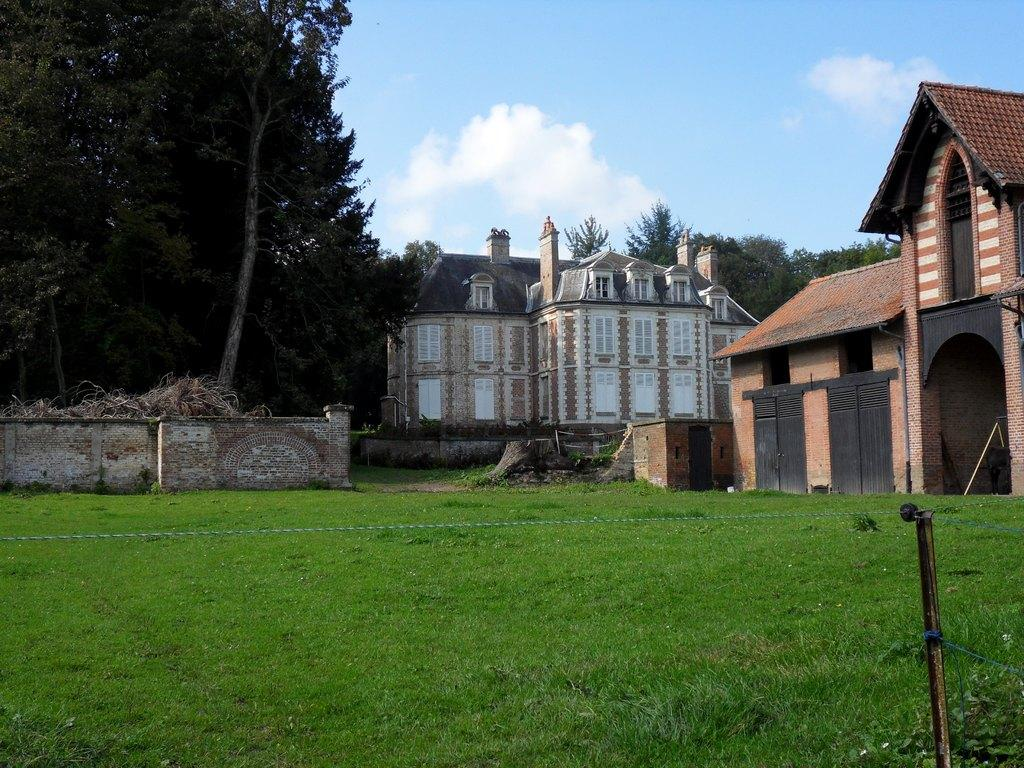What type of structures can be seen in the image? There are buildings in the image. What type of vegetation is present in the image? There are trees and grass in the image. What type of barrier can be seen in the image? There is a wall in the image. What part of the natural environment is visible in the image? The sky is visible in the image. What can be seen in the sky in the image? There are clouds in the image. How many jars of honey are being collected by the beggar in the image? There is no beggar or jar of honey present in the image. How many rabbits can be seen hopping around in the image? There are no rabbits present in the image. 